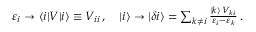Convert formula to latex. <formula><loc_0><loc_0><loc_500><loc_500>\begin{array} { r } { \varepsilon _ { i } \to \langle i | V | i \rangle \equiv V _ { i i } \, , \quad | i \rangle \to | \delta i \rangle = \sum _ { k \neq i } \frac { | k \rangle \, V _ { k i } } { \varepsilon _ { i } - \varepsilon _ { k } } \, . } \end{array}</formula> 